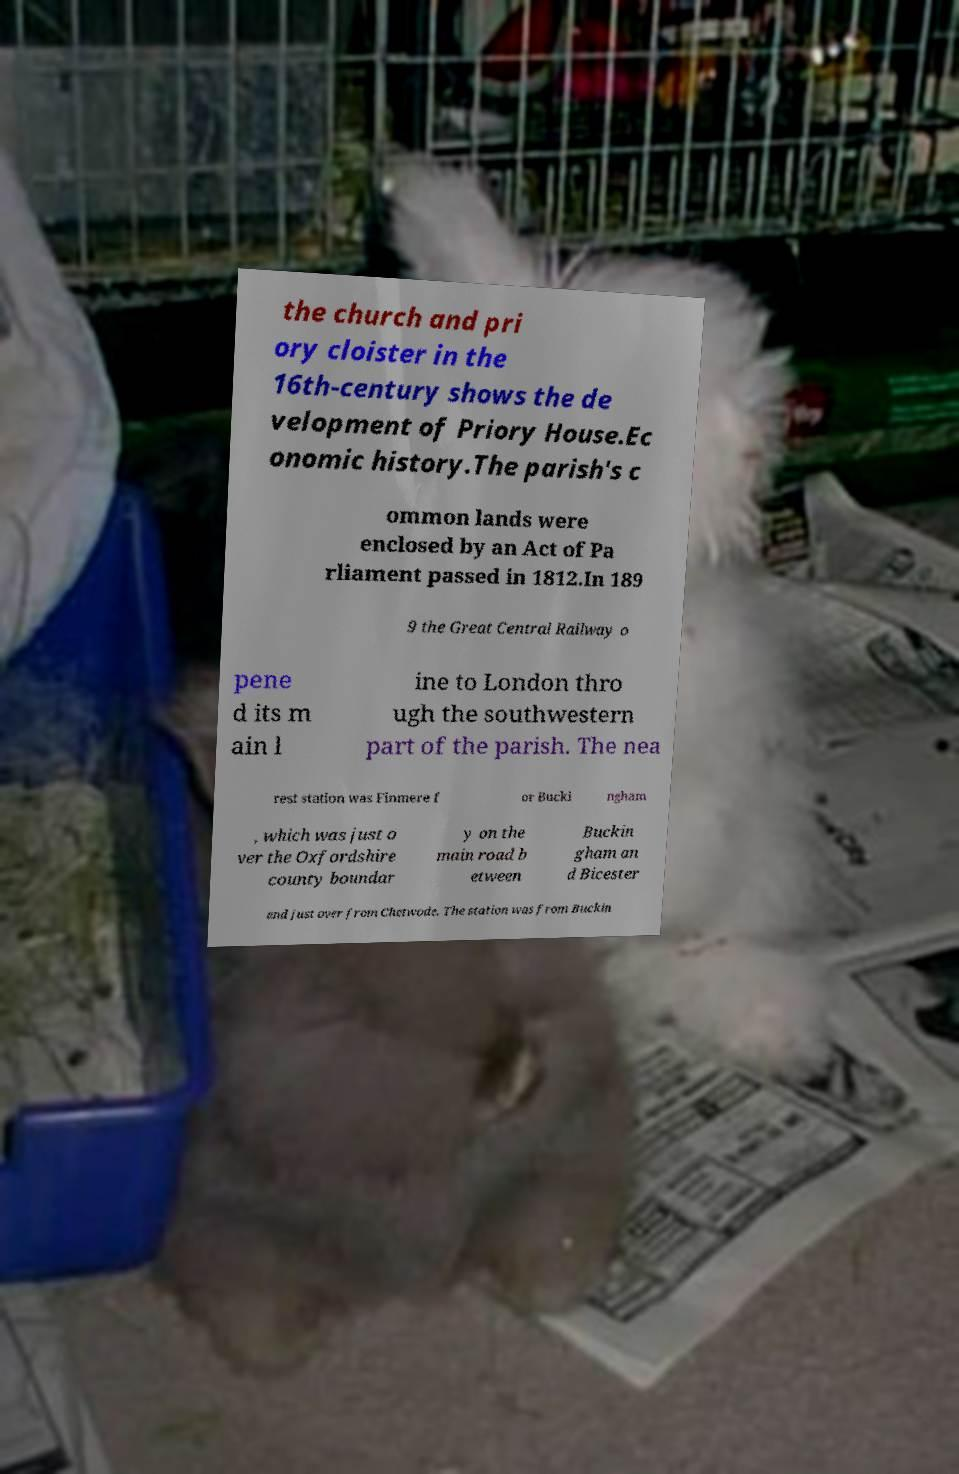Can you read and provide the text displayed in the image?This photo seems to have some interesting text. Can you extract and type it out for me? the church and pri ory cloister in the 16th-century shows the de velopment of Priory House.Ec onomic history.The parish's c ommon lands were enclosed by an Act of Pa rliament passed in 1812.In 189 9 the Great Central Railway o pene d its m ain l ine to London thro ugh the southwestern part of the parish. The nea rest station was Finmere f or Bucki ngham , which was just o ver the Oxfordshire county boundar y on the main road b etween Buckin gham an d Bicester and just over from Chetwode. The station was from Buckin 